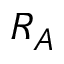Convert formula to latex. <formula><loc_0><loc_0><loc_500><loc_500>R _ { A }</formula> 